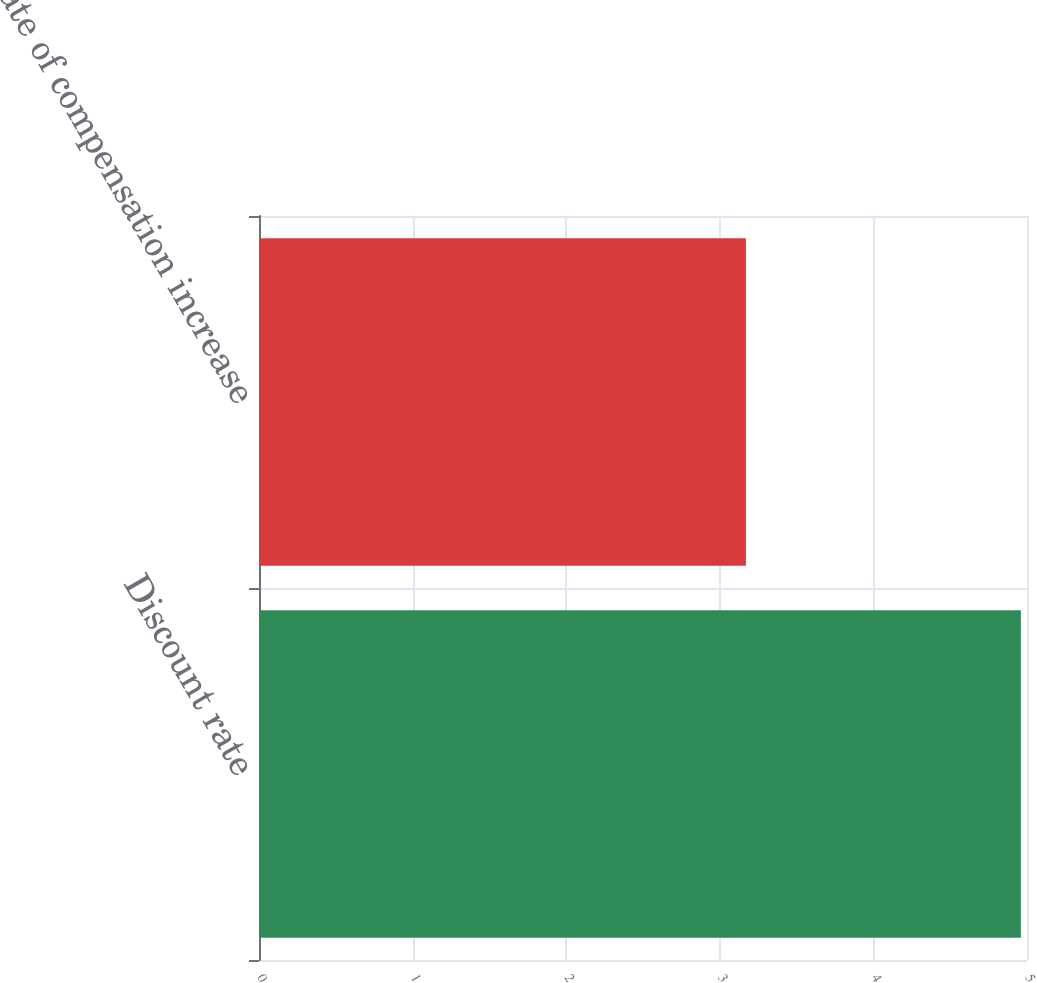Convert chart. <chart><loc_0><loc_0><loc_500><loc_500><bar_chart><fcel>Discount rate<fcel>Rate of compensation increase<nl><fcel>4.96<fcel>3.17<nl></chart> 